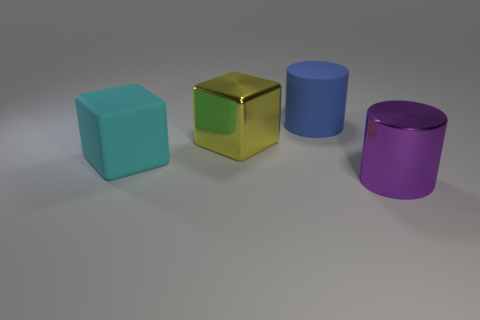Are there any yellow blocks of the same size as the matte cylinder?
Your response must be concise. Yes. Do the large cyan thing and the big cylinder behind the big cyan thing have the same material?
Give a very brief answer. Yes. Are there more large metal cubes than large gray rubber things?
Provide a succinct answer. Yes. How many blocks are either big blue matte things or big cyan rubber objects?
Provide a succinct answer. 1. The matte cube is what color?
Your answer should be very brief. Cyan. There is a thing in front of the large cyan thing; does it have the same size as the yellow metal block behind the cyan matte cube?
Ensure brevity in your answer.  Yes. Is the number of large matte cylinders less than the number of small red shiny cubes?
Provide a succinct answer. No. How many matte cylinders are to the left of the cyan rubber object?
Your answer should be very brief. 0. What is the material of the cyan object?
Offer a very short reply. Rubber. Does the metallic block have the same color as the matte block?
Your answer should be compact. No. 